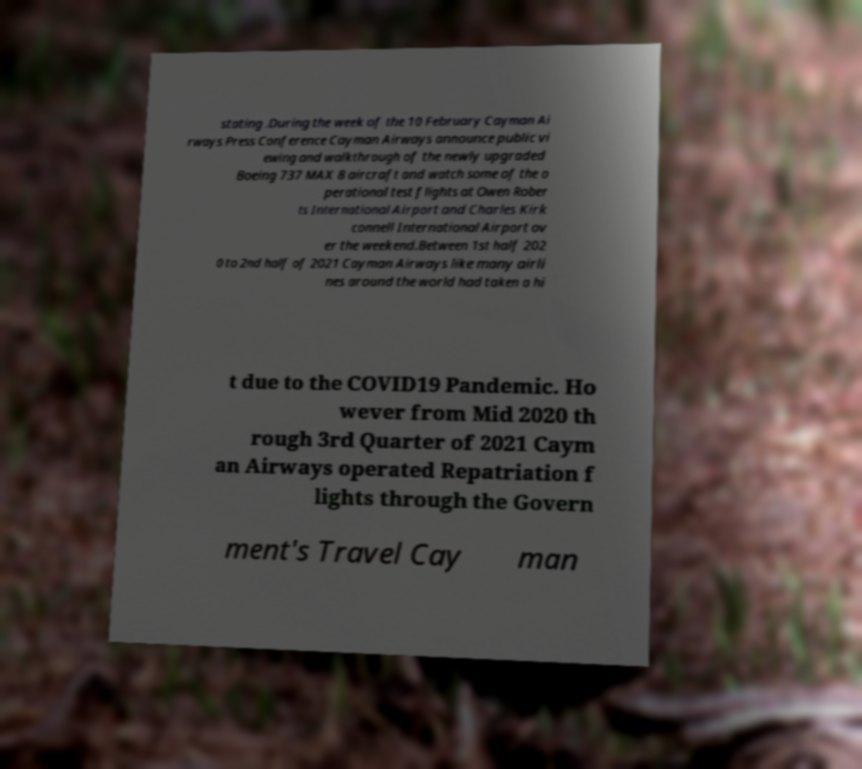Can you read and provide the text displayed in the image?This photo seems to have some interesting text. Can you extract and type it out for me? stating .During the week of the 10 February Cayman Ai rways Press Conference Cayman Airways announce public vi ewing and walkthrough of the newly upgraded Boeing 737 MAX 8 aircraft and watch some of the o perational test flights at Owen Rober ts International Airport and Charles Kirk connell International Airport ov er the weekend.Between 1st half 202 0 to 2nd half of 2021 Cayman Airways like many airli nes around the world had taken a hi t due to the COVID19 Pandemic. Ho wever from Mid 2020 th rough 3rd Quarter of 2021 Caym an Airways operated Repatriation f lights through the Govern ment's Travel Cay man 